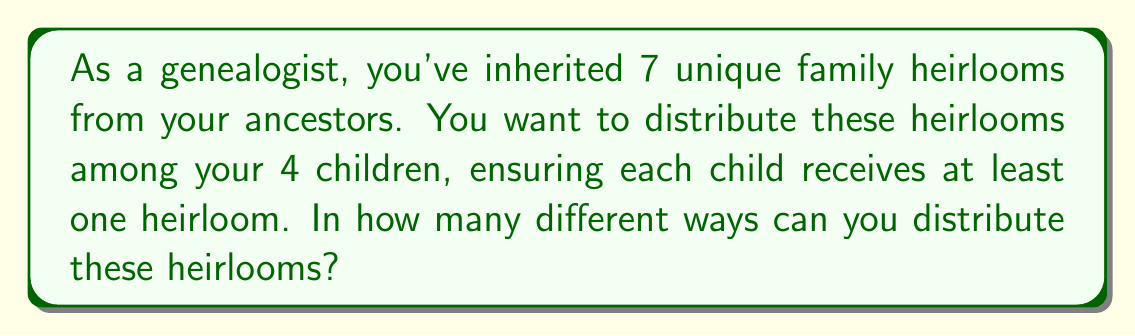Show me your answer to this math problem. Let's approach this step-by-step using the concept of Stirling numbers of the second kind and the multiplication principle:

1) This problem is equivalent to finding the number of ways to partition 7 distinct objects into 4 non-empty subsets.

2) The Stirling number of the second kind, denoted as $\stirling{n}{k}$, gives the number of ways to partition n distinct objects into k non-empty subsets.

3) In this case, we need $\stirling{7}{4}$.

4) The formula for $\stirling{7}{4}$ is:

   $$\stirling{7}{4} = \frac{1}{4!}\sum_{i=0}^4 (-1)^i \binom{4}{i}(4-i)^7$$

5) Expanding this:
   $$\stirling{7}{4} = \frac{1}{24}[(4^7) - \binom{4}{1}(3^7) + \binom{4}{2}(2^7) - \binom{4}{3}(1^7) + \binom{4}{4}(0^7)]$$

6) Calculating:
   $$\stirling{7}{4} = \frac{1}{24}[16384 - 4(2187) + 6(128) - 4(1) + 0] = \frac{1}{24}[16384 - 8748 + 768 - 4] = 350$$

7) However, this only gives us the number of ways to partition the heirlooms. We also need to consider the number of ways to assign these partitions to the 4 children.

8) There are 4! = 24 ways to assign 4 partitions to 4 children.

9) By the multiplication principle, the total number of ways to distribute the heirlooms is:

   $$350 \times 24 = 8400$$
Answer: 8400 